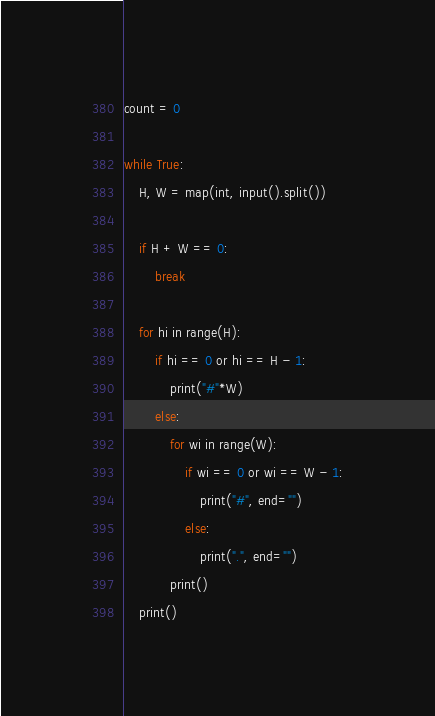Convert code to text. <code><loc_0><loc_0><loc_500><loc_500><_Python_>count = 0

while True:
    H, W = map(int, input().split())

    if H + W == 0:
        break

    for hi in range(H):
        if hi == 0 or hi == H - 1:
            print("#"*W)
        else:
            for wi in range(W):
                if wi == 0 or wi == W - 1:
                    print("#", end="")
                else:
                    print(".", end="")
            print()
    print()

</code> 